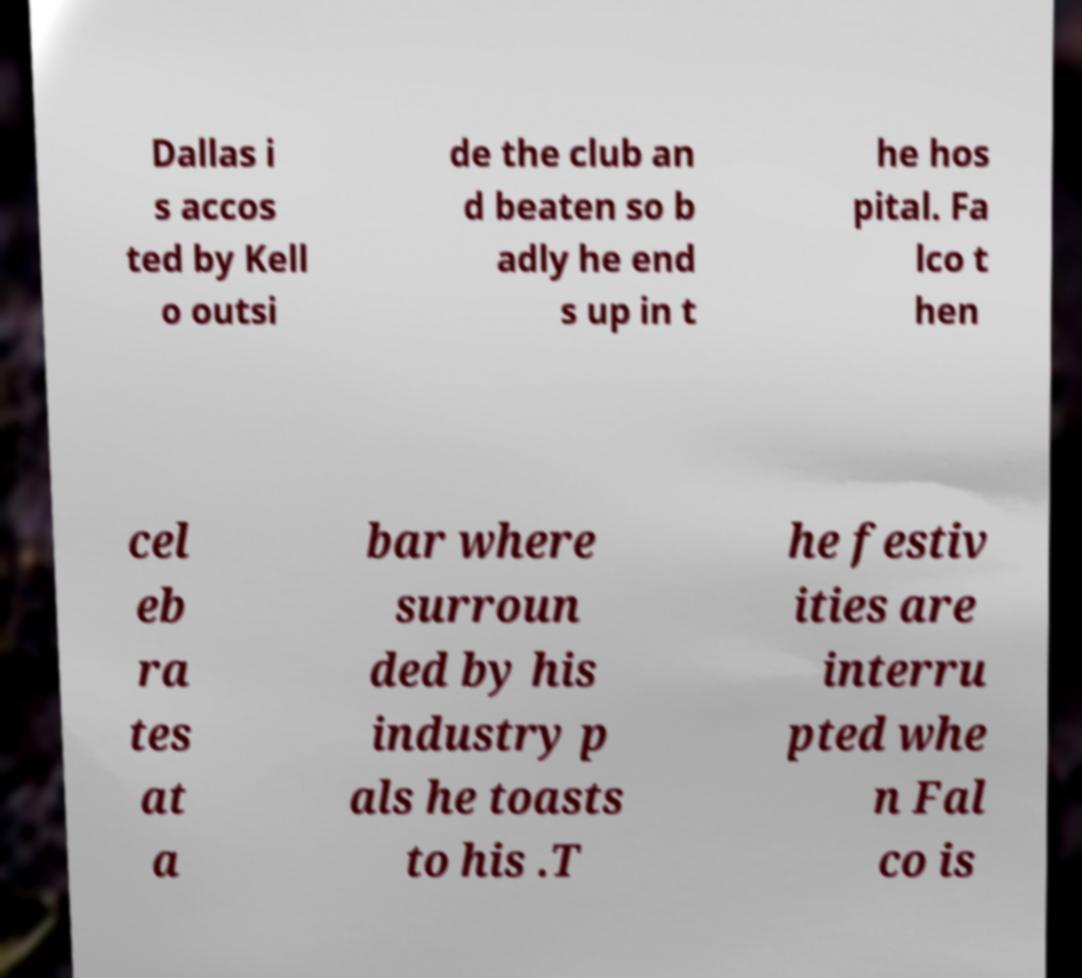Can you accurately transcribe the text from the provided image for me? Dallas i s accos ted by Kell o outsi de the club an d beaten so b adly he end s up in t he hos pital. Fa lco t hen cel eb ra tes at a bar where surroun ded by his industry p als he toasts to his .T he festiv ities are interru pted whe n Fal co is 